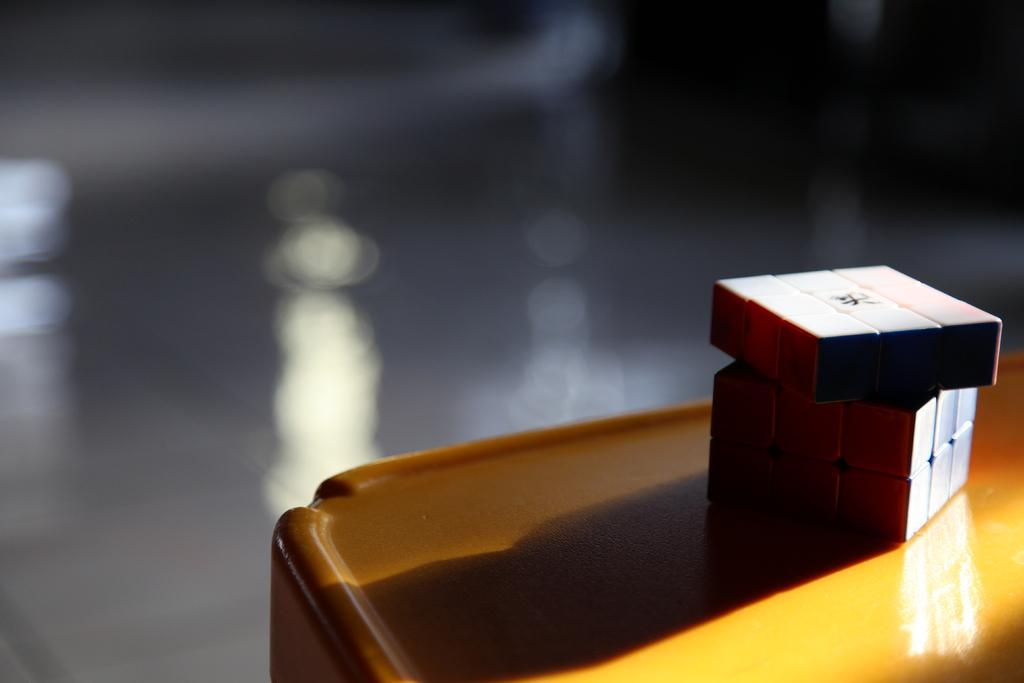What object is located on the right side of the image? There is a Rubik's cube in the image. Where is the Rubik's cube placed in the image? The Rubik's cube is placed on a table. What does the sister do with the Rubik's cube in the image? There is no mention of a sister in the image, so we cannot answer this question. 